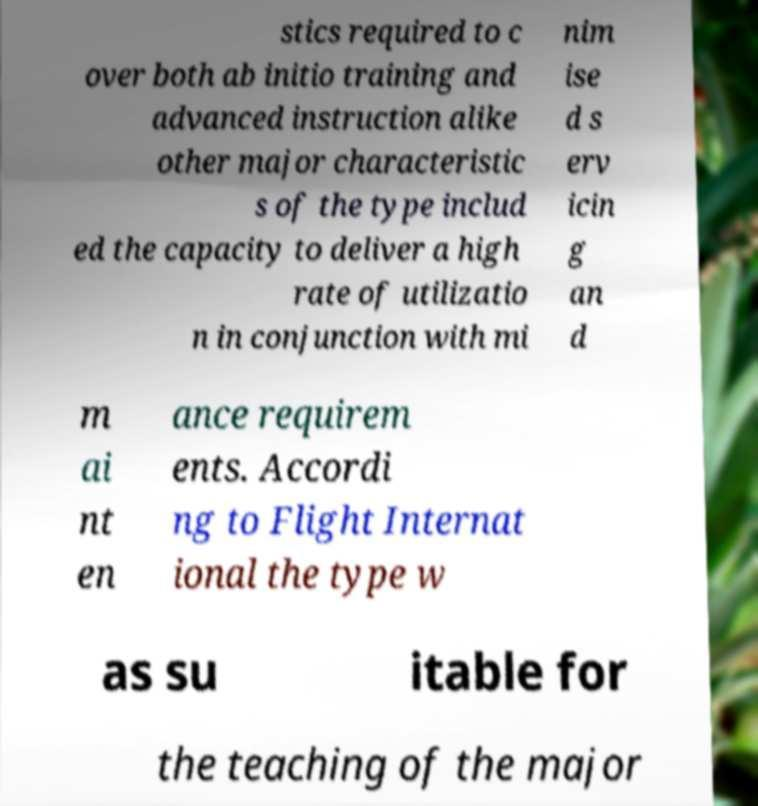What messages or text are displayed in this image? I need them in a readable, typed format. stics required to c over both ab initio training and advanced instruction alike other major characteristic s of the type includ ed the capacity to deliver a high rate of utilizatio n in conjunction with mi nim ise d s erv icin g an d m ai nt en ance requirem ents. Accordi ng to Flight Internat ional the type w as su itable for the teaching of the major 